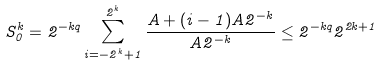Convert formula to latex. <formula><loc_0><loc_0><loc_500><loc_500>S _ { 0 } ^ { k } = 2 ^ { - k q } \sum _ { i = - 2 ^ { k } + 1 } ^ { 2 ^ { k } } \frac { A + ( i - 1 ) A 2 ^ { - k } } { A 2 ^ { - k } } \leq 2 ^ { - k q } 2 ^ { 2 k + 1 }</formula> 